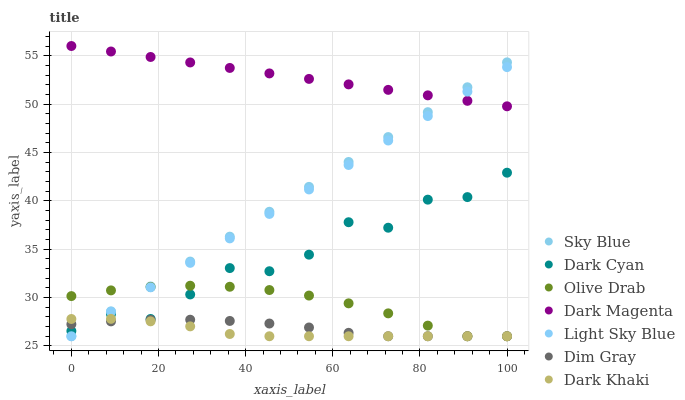Does Dark Khaki have the minimum area under the curve?
Answer yes or no. Yes. Does Dark Magenta have the maximum area under the curve?
Answer yes or no. Yes. Does Dark Magenta have the minimum area under the curve?
Answer yes or no. No. Does Dark Khaki have the maximum area under the curve?
Answer yes or no. No. Is Sky Blue the smoothest?
Answer yes or no. Yes. Is Dark Cyan the roughest?
Answer yes or no. Yes. Is Dark Magenta the smoothest?
Answer yes or no. No. Is Dark Magenta the roughest?
Answer yes or no. No. Does Dim Gray have the lowest value?
Answer yes or no. Yes. Does Dark Magenta have the lowest value?
Answer yes or no. No. Does Dark Magenta have the highest value?
Answer yes or no. Yes. Does Dark Khaki have the highest value?
Answer yes or no. No. Is Dim Gray less than Dark Magenta?
Answer yes or no. Yes. Is Dark Magenta greater than Dark Khaki?
Answer yes or no. Yes. Does Dark Cyan intersect Dark Khaki?
Answer yes or no. Yes. Is Dark Cyan less than Dark Khaki?
Answer yes or no. No. Is Dark Cyan greater than Dark Khaki?
Answer yes or no. No. Does Dim Gray intersect Dark Magenta?
Answer yes or no. No. 